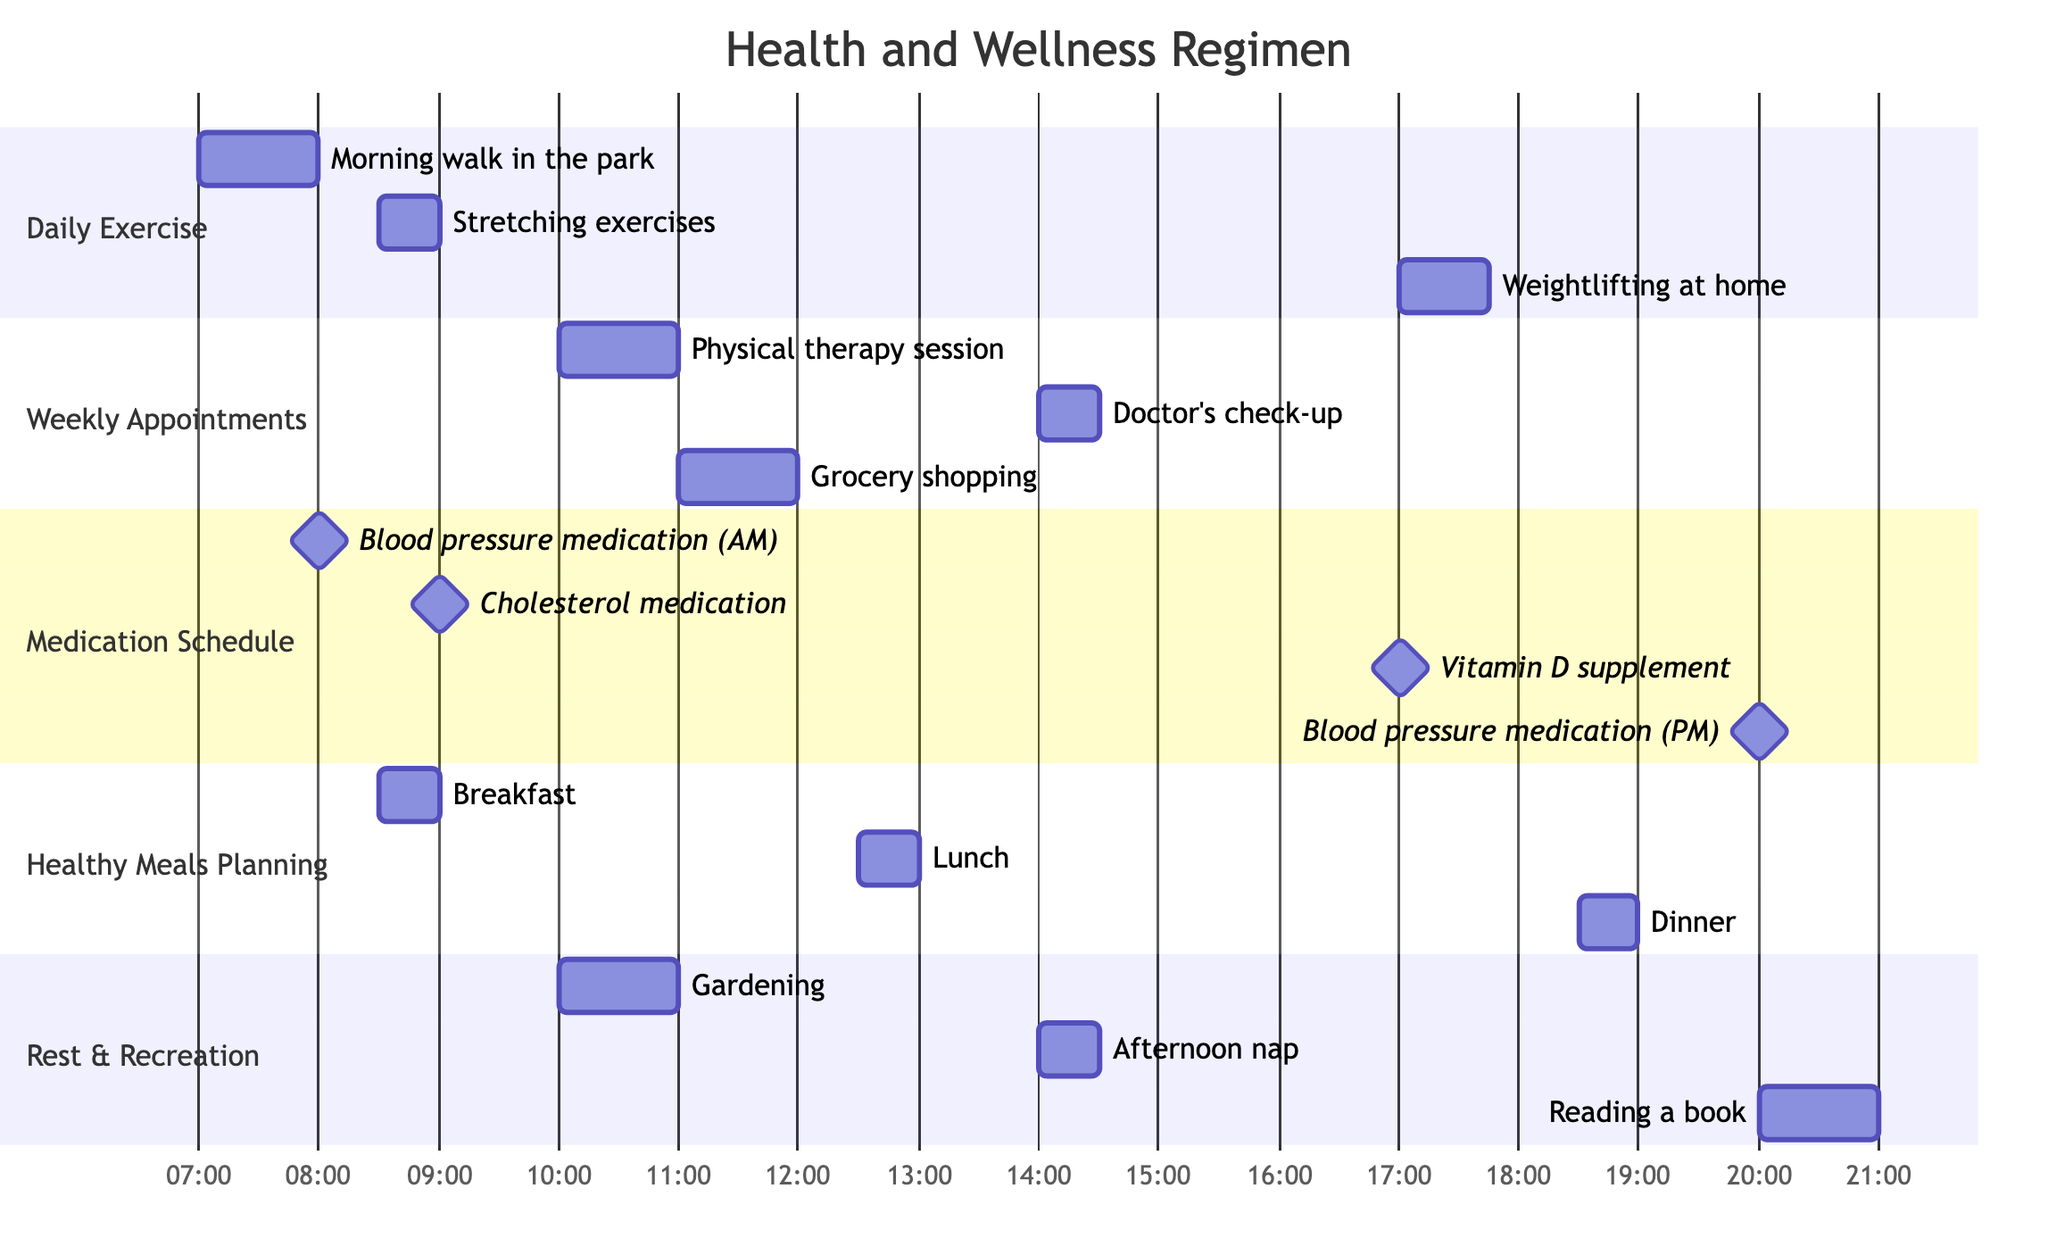What time does the morning walk in the park begin? The diagram lists the morning walk in the park under the "Daily Exercise" section, showing a start time of 7:00 AM.
Answer: 7:00 AM How long is the doctor's check-up scheduled for? The doctor's check-up is shown in the "Weekly Appointments" section with a duration of 30 minutes.
Answer: 30 minutes Which activity overlaps with the blood pressure medication in the morning? The blood pressure medication is scheduled at 8:00 AM, and the only upcoming activity at that time is the breakfast activity starting at 8:30 AM, which does not overlap but follows directly after it.
Answer: None What is the duration of the afternoon nap? The afternoon nap is indicated in the "Rest & Recreation" section with a specified duration of 30 minutes.
Answer: 30 minutes What activities occur at 10:00 AM? The diagram shows two activities at 10:00 AM: the physical therapy session and gardening, both listed at that time.
Answer: Physical therapy session, Gardening How many medication times are scheduled in the evening? In the "Medication Schedule" section, the blood pressure medication is scheduled for 8:00 PM and the vitamin D supplement is taken at 5:00 PM, making a total of one evening medication time directly noted.
Answer: 1 Which meal is scheduled right before weightlifting? Weightlifting at home begins at 5:00 PM, and the last meal listed before that is lunch scheduled at 12:30 PM, which ends before the weightlifting begins.
Answer: Lunch What is the total number of daily exercises listed? The "Daily Exercise" section shows three distinct activities: morning walk, stretching exercises, and weightlifting, counting them gives a total of three exercises listed.
Answer: 3 How many total weekly appointments are there? The "Weekly Appointments" section lists three distinct appointments: physical therapy session, doctor's check-up, and grocery shopping, totaling to three appointments overall.
Answer: 3 